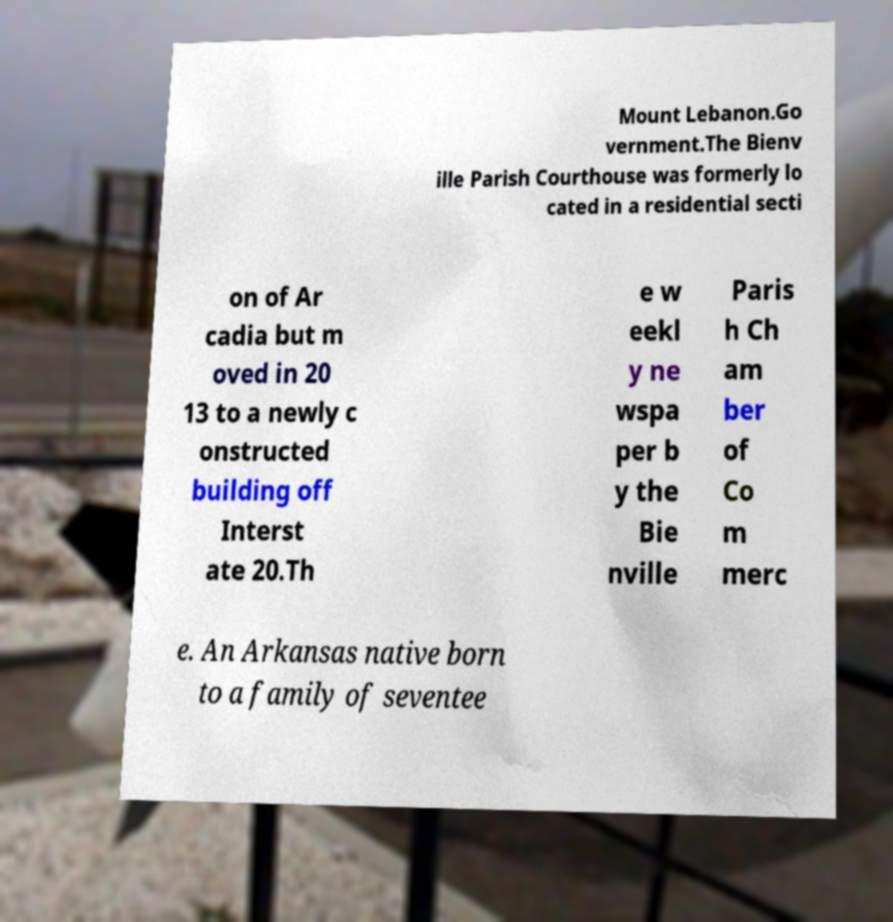I need the written content from this picture converted into text. Can you do that? Mount Lebanon.Go vernment.The Bienv ille Parish Courthouse was formerly lo cated in a residential secti on of Ar cadia but m oved in 20 13 to a newly c onstructed building off Interst ate 20.Th e w eekl y ne wspa per b y the Bie nville Paris h Ch am ber of Co m merc e. An Arkansas native born to a family of seventee 